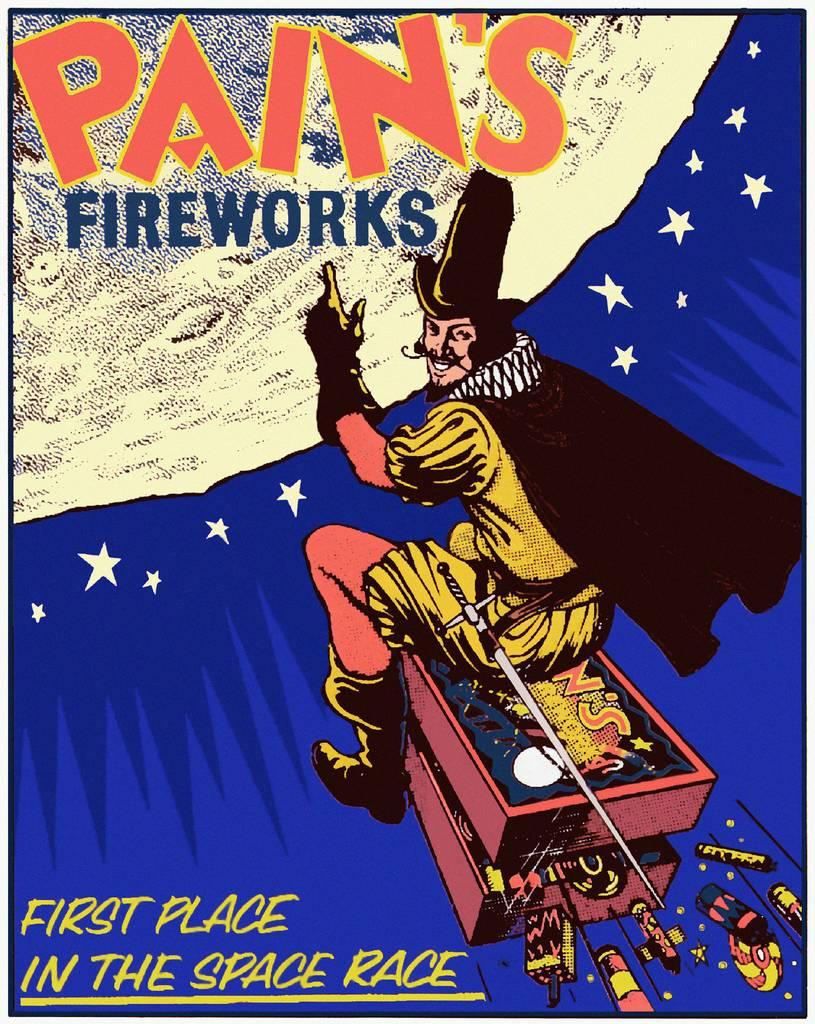<image>
Describe the image concisely. Poster with the text saying Pain's Fireworks First Place in the Space Race. 